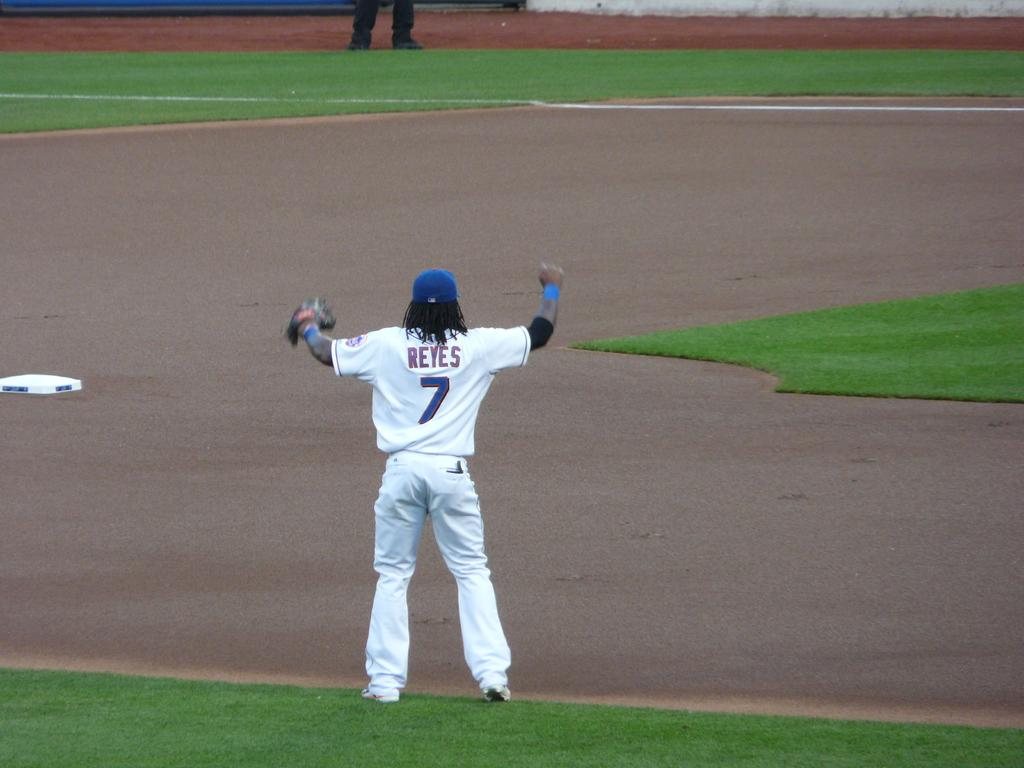Provide a one-sentence caption for the provided image. a baseball player whose last name is reyes and wears the number 7 uniform. 